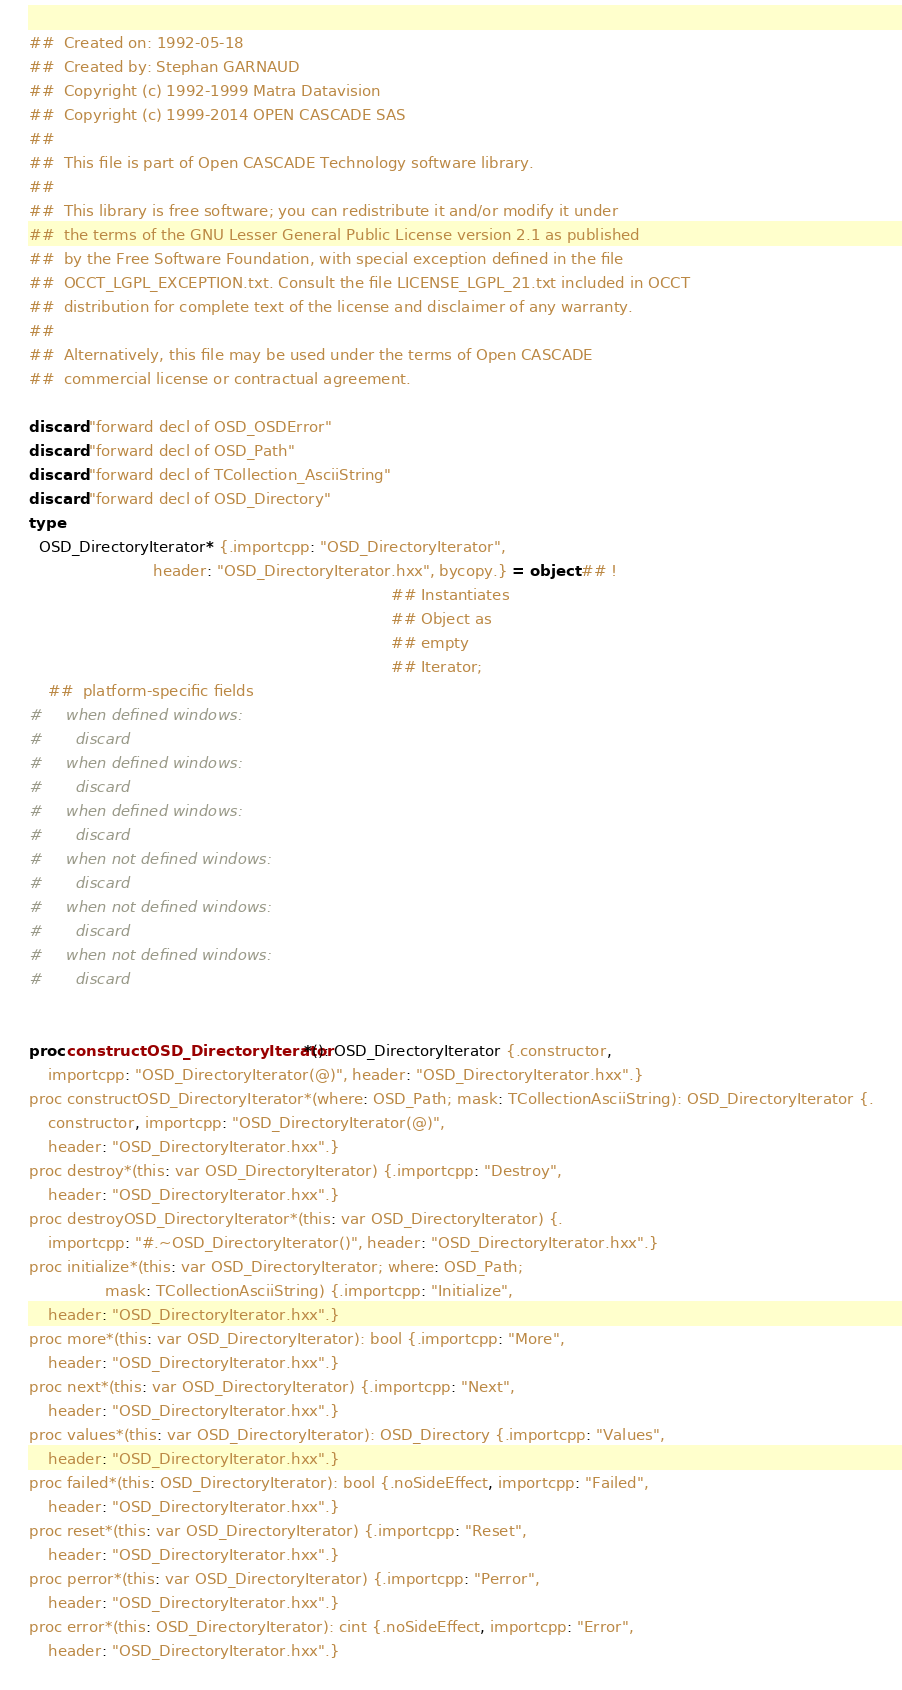Convert code to text. <code><loc_0><loc_0><loc_500><loc_500><_Nim_>##  Created on: 1992-05-18
##  Created by: Stephan GARNAUD
##  Copyright (c) 1992-1999 Matra Datavision
##  Copyright (c) 1999-2014 OPEN CASCADE SAS
##
##  This file is part of Open CASCADE Technology software library.
##
##  This library is free software; you can redistribute it and/or modify it under
##  the terms of the GNU Lesser General Public License version 2.1 as published
##  by the Free Software Foundation, with special exception defined in the file
##  OCCT_LGPL_EXCEPTION.txt. Consult the file LICENSE_LGPL_21.txt included in OCCT
##  distribution for complete text of the license and disclaimer of any warranty.
##
##  Alternatively, this file may be used under the terms of Open CASCADE
##  commercial license or contractual agreement.

discard "forward decl of OSD_OSDError"
discard "forward decl of OSD_Path"
discard "forward decl of TCollection_AsciiString"
discard "forward decl of OSD_Directory"
type
  OSD_DirectoryIterator* {.importcpp: "OSD_DirectoryIterator",
                          header: "OSD_DirectoryIterator.hxx", bycopy.} = object ## !
                                                                            ## Instantiates
                                                                            ## Object as
                                                                            ## empty
                                                                            ## Iterator;
    ##  platform-specific fields
#     when defined windows:
#       discard
#     when defined windows:
#       discard
#     when defined windows:
#       discard
#     when not defined windows:
#       discard
#     when not defined windows:
#       discard
#     when not defined windows:
#       discard


proc constructOSD_DirectoryIterator*(): OSD_DirectoryIterator {.constructor,
    importcpp: "OSD_DirectoryIterator(@)", header: "OSD_DirectoryIterator.hxx".}
proc constructOSD_DirectoryIterator*(where: OSD_Path; mask: TCollectionAsciiString): OSD_DirectoryIterator {.
    constructor, importcpp: "OSD_DirectoryIterator(@)",
    header: "OSD_DirectoryIterator.hxx".}
proc destroy*(this: var OSD_DirectoryIterator) {.importcpp: "Destroy",
    header: "OSD_DirectoryIterator.hxx".}
proc destroyOSD_DirectoryIterator*(this: var OSD_DirectoryIterator) {.
    importcpp: "#.~OSD_DirectoryIterator()", header: "OSD_DirectoryIterator.hxx".}
proc initialize*(this: var OSD_DirectoryIterator; where: OSD_Path;
                mask: TCollectionAsciiString) {.importcpp: "Initialize",
    header: "OSD_DirectoryIterator.hxx".}
proc more*(this: var OSD_DirectoryIterator): bool {.importcpp: "More",
    header: "OSD_DirectoryIterator.hxx".}
proc next*(this: var OSD_DirectoryIterator) {.importcpp: "Next",
    header: "OSD_DirectoryIterator.hxx".}
proc values*(this: var OSD_DirectoryIterator): OSD_Directory {.importcpp: "Values",
    header: "OSD_DirectoryIterator.hxx".}
proc failed*(this: OSD_DirectoryIterator): bool {.noSideEffect, importcpp: "Failed",
    header: "OSD_DirectoryIterator.hxx".}
proc reset*(this: var OSD_DirectoryIterator) {.importcpp: "Reset",
    header: "OSD_DirectoryIterator.hxx".}
proc perror*(this: var OSD_DirectoryIterator) {.importcpp: "Perror",
    header: "OSD_DirectoryIterator.hxx".}
proc error*(this: OSD_DirectoryIterator): cint {.noSideEffect, importcpp: "Error",
    header: "OSD_DirectoryIterator.hxx".}

























</code> 